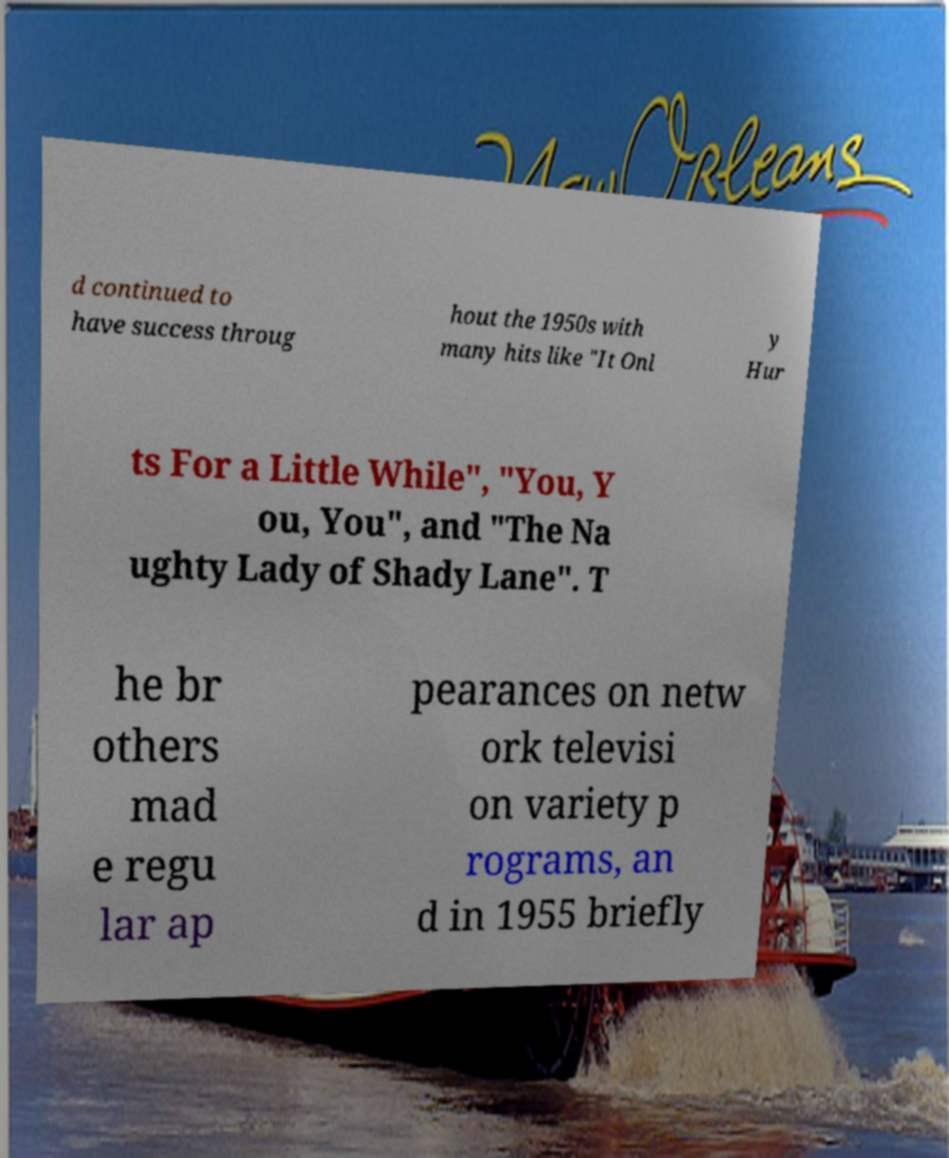Could you extract and type out the text from this image? d continued to have success throug hout the 1950s with many hits like "It Onl y Hur ts For a Little While", "You, Y ou, You", and "The Na ughty Lady of Shady Lane". T he br others mad e regu lar ap pearances on netw ork televisi on variety p rograms, an d in 1955 briefly 